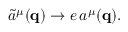<formula> <loc_0><loc_0><loc_500><loc_500>\tilde { a } ^ { \mu } ( { q } ) \rightarrow e \, a ^ { \mu } ( { q } ) .</formula> 